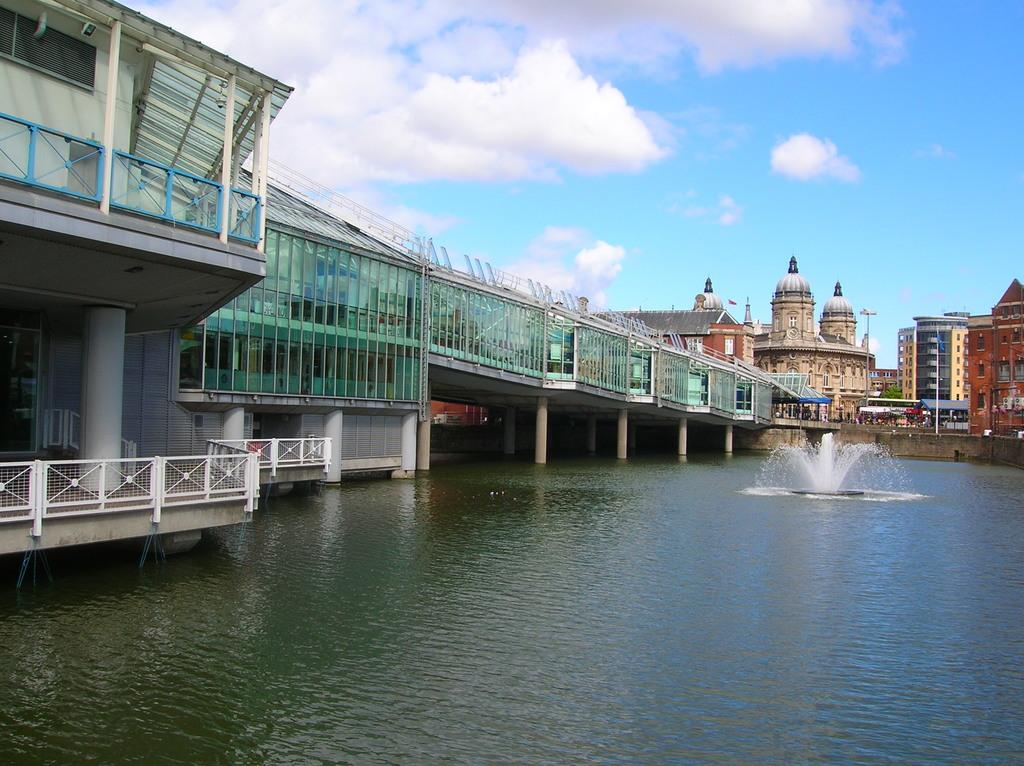What type of structures can be seen in the image? There are buildings and houses with roofs in the image. Can you describe any specific architectural features in the image? There is a bridge with pillars in the image. What else can be seen in the image besides buildings and houses? There are poles and a fountain in the image. Is there any natural element present in the image? Yes, there is a water body in the image. How would you describe the sky in the image? The sky is visible in the image and appears cloudy. What type of interest is the carpenter charging for their services during the holiday in the image? There is no carpenter or holiday mentioned in the image, so it is not possible to determine the interest rate or any services being provided. 